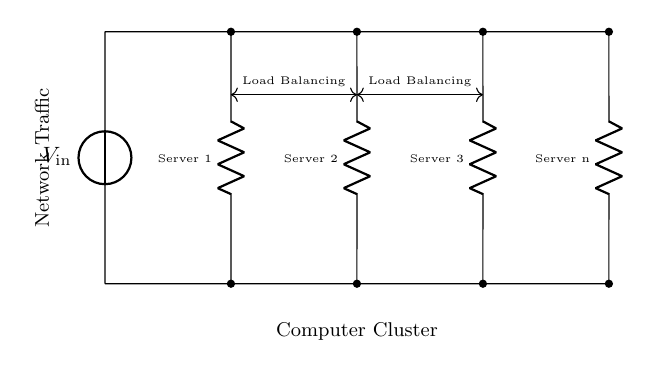What type of circuit is represented? The circuit diagram depicts a parallel circuit, as multiple resistors are connected side by side between the same two nodes.
Answer: Parallel How many servers are illustrated in the circuit? The circuit shows four servers represented as resistors, labeled from Server 1 to Server n. Counting them gives a total of four.
Answer: Four What do the dashed lines signify? The dashed lines connect the points of the circuit, indicating a separation or boundary mark, often used to signify segments that can be observed separately.
Answer: Separation What is the role of the load balancing arrows? The arrows indicate the concept of load balancing between the servers, suggesting that traffic is distributed evenly across the servers.
Answer: Load balancing What voltage is presented in the circuit? The voltage is labeled as V_in, specifying the input voltage that is supplied to the parallel circuit.
Answer: V_in If one server fails, what happens to the remaining servers? In a parallel circuit, if one server (resistor) fails, the remaining servers still function, allowing the overall circuit to continue operating without interruption.
Answer: Continue operating What happens to the total resistance when more servers are added to the circuit? Adding more resistors in parallel decreases the total resistance since the total resistance formula for parallel components indicates that the effective resistance decreases.
Answer: Decreases 